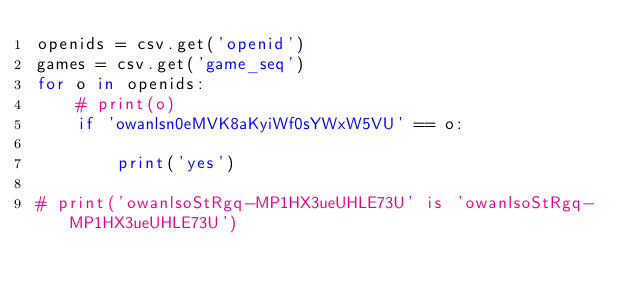<code> <loc_0><loc_0><loc_500><loc_500><_Python_>openids = csv.get('openid')
games = csv.get('game_seq')
for o in openids:
    # print(o)
    if 'owanlsn0eMVK8aKyiWf0sYWxW5VU' == o:

        print('yes')

# print('owanlsoStRgq-MP1HX3ueUHLE73U' is 'owanlsoStRgq-MP1HX3ueUHLE73U')</code> 